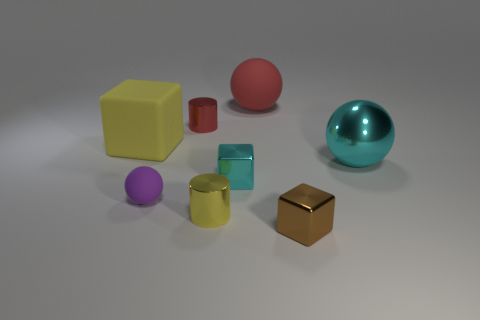Subtract all metallic balls. How many balls are left? 2 Add 1 cyan shiny things. How many objects exist? 9 Subtract all purple spheres. How many spheres are left? 2 Subtract all spheres. How many objects are left? 5 Subtract all blue balls. Subtract all cyan cylinders. How many balls are left? 3 Add 1 tiny metallic cubes. How many tiny metallic cubes exist? 3 Subtract 0 cyan cylinders. How many objects are left? 8 Subtract all tiny matte spheres. Subtract all cyan metal things. How many objects are left? 5 Add 8 big red objects. How many big red objects are left? 9 